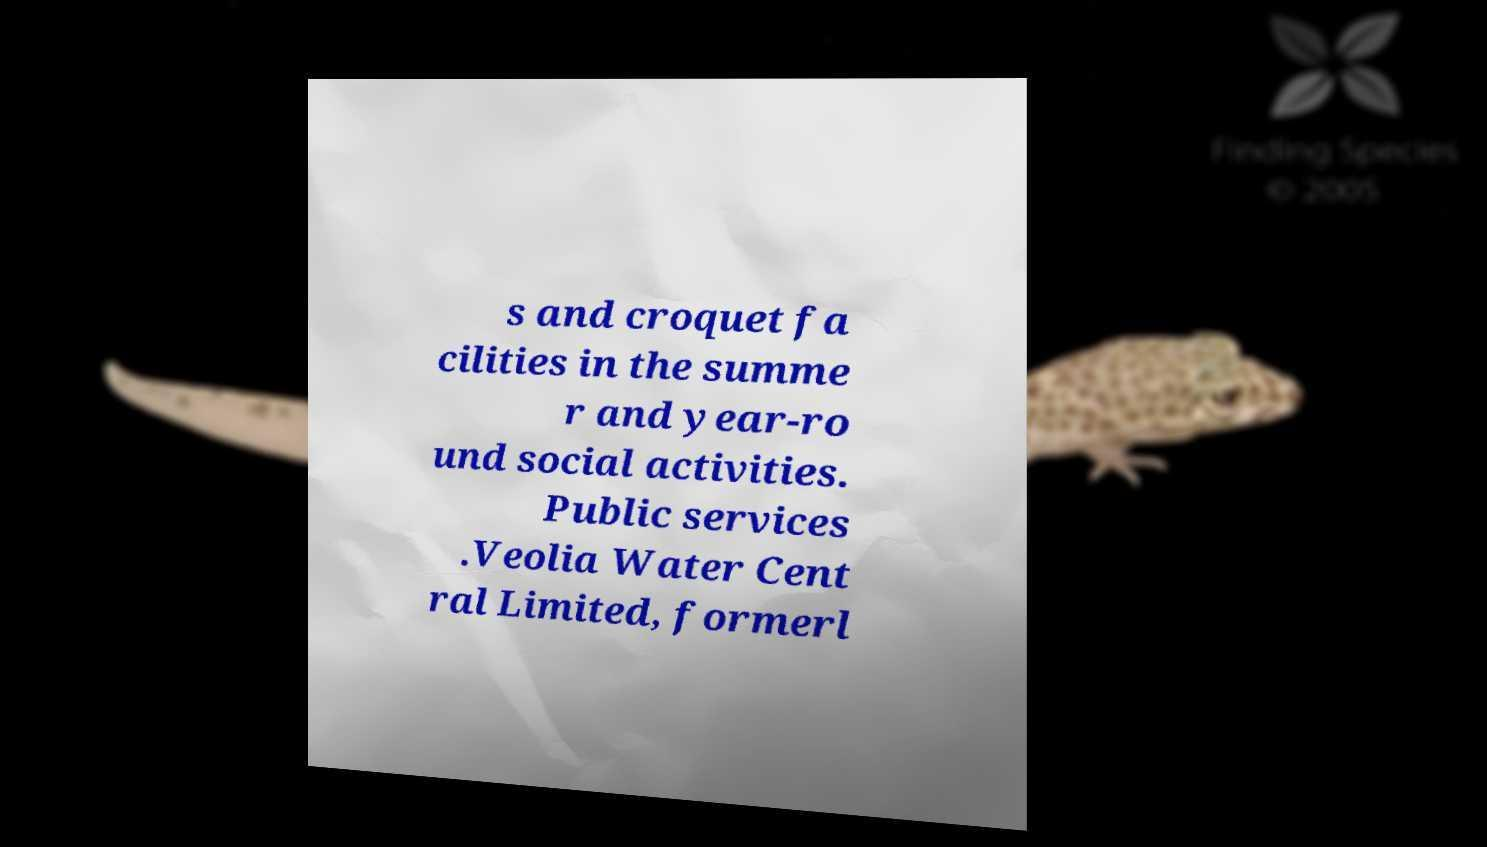For documentation purposes, I need the text within this image transcribed. Could you provide that? s and croquet fa cilities in the summe r and year-ro und social activities. Public services .Veolia Water Cent ral Limited, formerl 